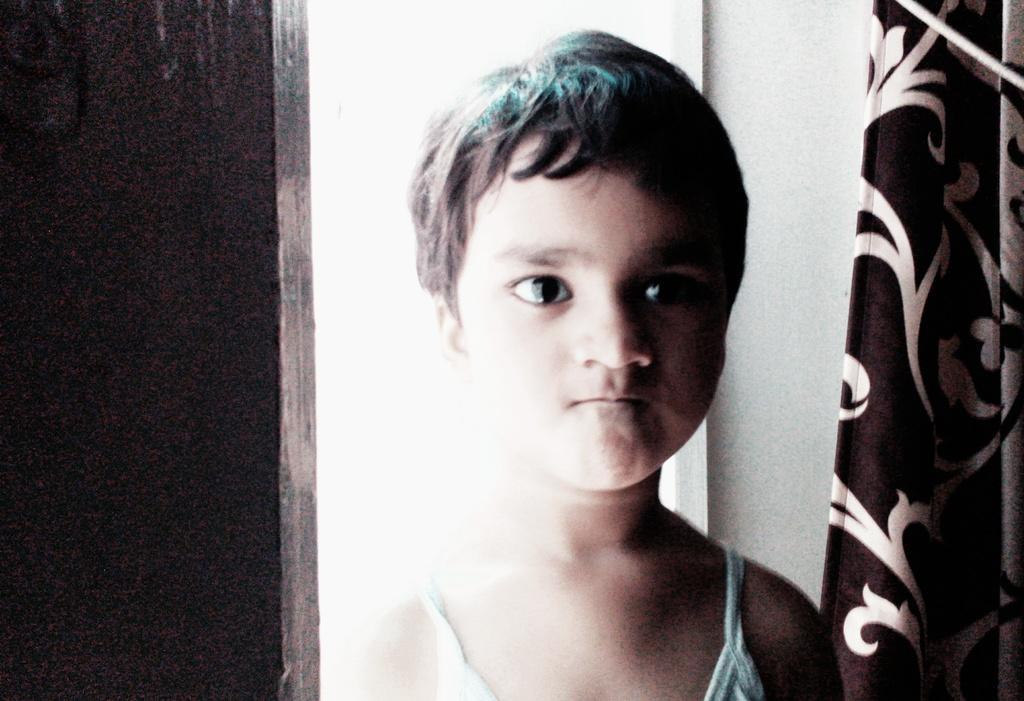Can you describe this image briefly? In this picture there is a kid wearing blue dress is standing and there is a brown and white color curtain in the right corner. 